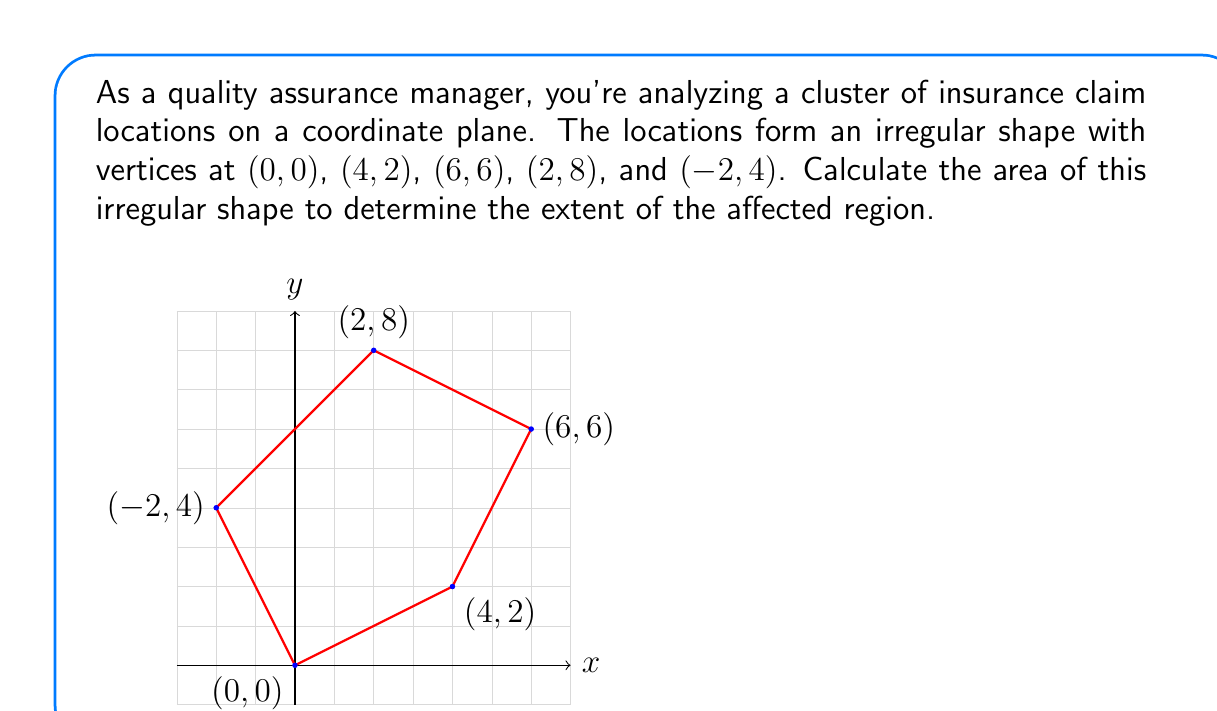Can you solve this math problem? To calculate the area of this irregular shape, we can use the Shoelace formula (also known as the surveyor's formula). This method is particularly useful for finding the area of a polygon given its vertices.

The Shoelace formula is:

$$ A = \frac{1}{2}\left|\sum_{i=1}^{n-1} (x_iy_{i+1} + x_ny_1) - \sum_{i=1}^{n-1} (y_ix_{i+1} + y_nx_1)\right| $$

Where $(x_i, y_i)$ are the coordinates of the $i$-th vertex, and $n$ is the number of vertices.

Let's apply this formula to our vertices:
(0, 0), (4, 2), (6, 6), (2, 8), (-2, 4)

Step 1: Calculate the first sum:
$$(0 \cdot 2) + (4 \cdot 6) + (6 \cdot 8) + (2 \cdot 4) + (-2 \cdot 0) = 0 + 24 + 48 + 8 + 0 = 80$$

Step 2: Calculate the second sum:
$$(0 \cdot 4) + (2 \cdot 6) + (6 \cdot 2) + (8 \cdot -2) + (4 \cdot 0) = 0 + 12 + 12 - 16 + 0 = 8$$

Step 3: Subtract the second sum from the first:
$$80 - 8 = 72$$

Step 4: Take the absolute value and divide by 2:
$$\frac{1}{2}|72| = 36$$

Therefore, the area of the irregular shape is 36 square units.
Answer: $36$ square units 